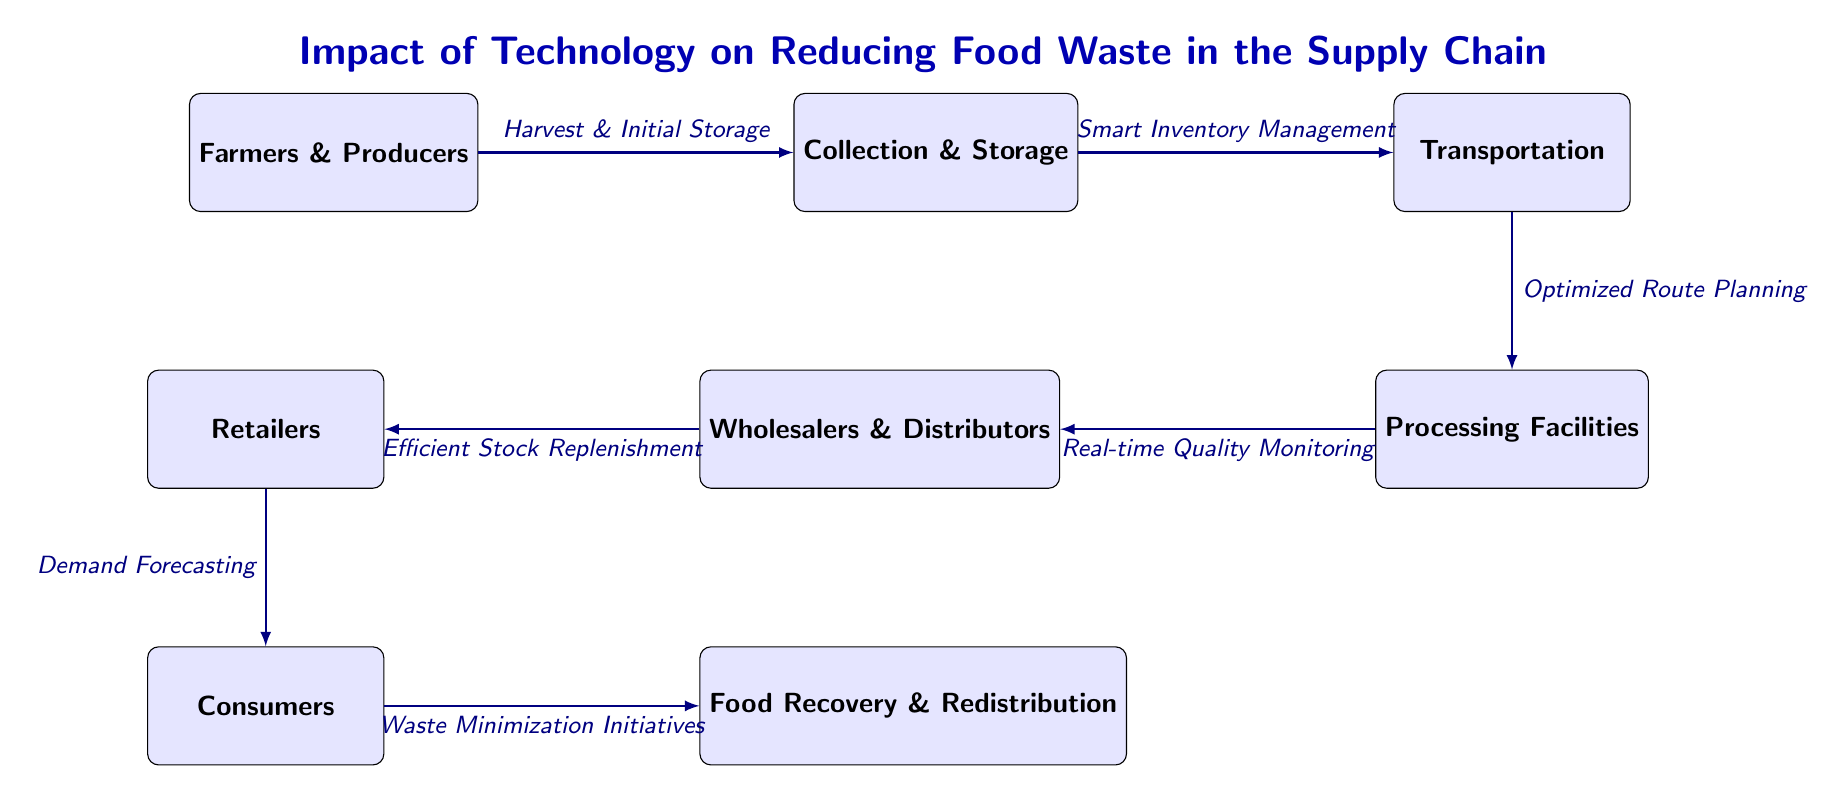What are the first two nodes in the supply chain? The first two nodes in the supply chain, as represented in the diagram, are "Farmers & Producers" followed by "Collection & Storage." These nodes are positioned at the left side of the diagram and indicate the initial stages of the food supply chain.
Answer: Farmers & Producers, Collection & Storage How many nodes are in the diagram? The diagram displays a total of eight nodes representing various stages of the food supply chain, from production through to consumption and recovery. Each node corresponds to a specific entity in the food supply chain.
Answer: 8 What is the label between Transportation and Processing Facilities? The label between "Transportation" and "Processing Facilities" is "Optimized Route Planning." This indicates the technology used to enhance the efficiency of transporting food products.
Answer: Optimized Route Planning Which node follows Wholesalers & Distributors? Following "Wholesalers & Distributors" is "Retailers." The flow of the diagram connects these nodes, showing the progression of food products through the supply chain.
Answer: Retailers What technology aids in demand forecasting? The technology that supports demand forecasting is indicated in the flow from "Retailers" to "Consumers." This node is labeled as "Demand Forecasting," representing methods used to predict consumer needs.
Answer: Demand Forecasting What is the final destination of food products in the supply chain? The final destination of food products in the supply chain, as depicted in the diagram, is the "Food Recovery & Redistribution" stage, following "Consumers." This reflects the endpoint that addresses waste reduction and recovery initiatives.
Answer: Food Recovery & Redistribution What is the relationship between Processing Facilities and Wholesalers & Distributors? The relationship is represented by the label "Real-time Quality Monitoring." This indicates the feedback loop from processing to distribution, ensuring quality is maintained before reaching retailers.
Answer: Real-time Quality Monitoring Which process is listed above the arrow from Consumers to Food Recovery & Redistribution? The process listed above the arrow from "Consumers" to "Food Recovery & Redistribution" is "Waste Minimization Initiatives." This highlights efforts to reduce waste at the consumer level.
Answer: Waste Minimization Initiatives 